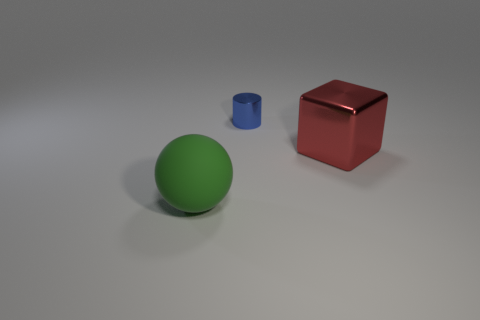Are there any other things that are the same material as the green object?
Ensure brevity in your answer.  No. Are there any other things that are the same size as the blue object?
Keep it short and to the point. No. What number of objects are objects in front of the red cube or big things that are on the right side of the metal cylinder?
Make the answer very short. 2. What number of other objects are there of the same material as the blue object?
Your answer should be very brief. 1. Do the big thing to the right of the blue metallic object and the tiny cylinder have the same material?
Your response must be concise. Yes. Are there more big green rubber objects that are right of the tiny object than big red things that are in front of the large matte sphere?
Give a very brief answer. No. What number of things are either objects that are in front of the block or red things?
Provide a succinct answer. 2. There is a big object that is the same material as the small cylinder; what shape is it?
Offer a terse response. Cube. Is there any other thing that has the same shape as the rubber thing?
Your answer should be very brief. No. There is a thing that is in front of the blue metal cylinder and behind the large matte object; what color is it?
Provide a short and direct response. Red. 